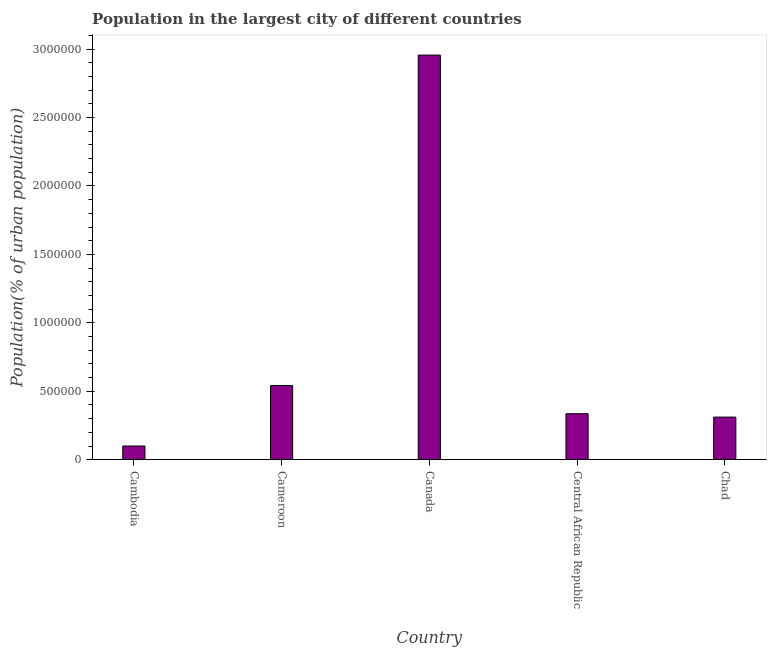What is the title of the graph?
Your answer should be compact. Population in the largest city of different countries. What is the label or title of the X-axis?
Offer a terse response. Country. What is the label or title of the Y-axis?
Your response must be concise. Population(% of urban population). What is the population in largest city in Central African Republic?
Your answer should be compact. 3.36e+05. Across all countries, what is the maximum population in largest city?
Offer a terse response. 2.96e+06. In which country was the population in largest city minimum?
Provide a short and direct response. Cambodia. What is the sum of the population in largest city?
Keep it short and to the point. 4.25e+06. What is the difference between the population in largest city in Cambodia and Central African Republic?
Your answer should be very brief. -2.36e+05. What is the average population in largest city per country?
Ensure brevity in your answer.  8.49e+05. What is the median population in largest city?
Provide a short and direct response. 3.36e+05. In how many countries, is the population in largest city greater than 2000000 %?
Make the answer very short. 1. What is the ratio of the population in largest city in Cambodia to that in Chad?
Your answer should be very brief. 0.32. Is the population in largest city in Canada less than that in Central African Republic?
Your answer should be very brief. No. What is the difference between the highest and the second highest population in largest city?
Make the answer very short. 2.41e+06. Is the sum of the population in largest city in Cameroon and Canada greater than the maximum population in largest city across all countries?
Your answer should be compact. Yes. What is the difference between the highest and the lowest population in largest city?
Offer a terse response. 2.86e+06. How many countries are there in the graph?
Ensure brevity in your answer.  5. What is the difference between two consecutive major ticks on the Y-axis?
Ensure brevity in your answer.  5.00e+05. Are the values on the major ticks of Y-axis written in scientific E-notation?
Your response must be concise. No. What is the Population(% of urban population) of Cambodia?
Ensure brevity in your answer.  1.00e+05. What is the Population(% of urban population) of Cameroon?
Your response must be concise. 5.42e+05. What is the Population(% of urban population) of Canada?
Make the answer very short. 2.96e+06. What is the Population(% of urban population) in Central African Republic?
Your response must be concise. 3.36e+05. What is the Population(% of urban population) of Chad?
Your answer should be compact. 3.11e+05. What is the difference between the Population(% of urban population) in Cambodia and Cameroon?
Give a very brief answer. -4.42e+05. What is the difference between the Population(% of urban population) in Cambodia and Canada?
Ensure brevity in your answer.  -2.86e+06. What is the difference between the Population(% of urban population) in Cambodia and Central African Republic?
Offer a very short reply. -2.36e+05. What is the difference between the Population(% of urban population) in Cambodia and Chad?
Give a very brief answer. -2.11e+05. What is the difference between the Population(% of urban population) in Cameroon and Canada?
Your answer should be very brief. -2.41e+06. What is the difference between the Population(% of urban population) in Cameroon and Central African Republic?
Give a very brief answer. 2.06e+05. What is the difference between the Population(% of urban population) in Cameroon and Chad?
Give a very brief answer. 2.31e+05. What is the difference between the Population(% of urban population) in Canada and Central African Republic?
Ensure brevity in your answer.  2.62e+06. What is the difference between the Population(% of urban population) in Canada and Chad?
Your answer should be very brief. 2.65e+06. What is the difference between the Population(% of urban population) in Central African Republic and Chad?
Make the answer very short. 2.47e+04. What is the ratio of the Population(% of urban population) in Cambodia to that in Cameroon?
Provide a short and direct response. 0.18. What is the ratio of the Population(% of urban population) in Cambodia to that in Canada?
Make the answer very short. 0.03. What is the ratio of the Population(% of urban population) in Cambodia to that in Central African Republic?
Your answer should be very brief. 0.3. What is the ratio of the Population(% of urban population) in Cambodia to that in Chad?
Ensure brevity in your answer.  0.32. What is the ratio of the Population(% of urban population) in Cameroon to that in Canada?
Offer a very short reply. 0.18. What is the ratio of the Population(% of urban population) in Cameroon to that in Central African Republic?
Make the answer very short. 1.61. What is the ratio of the Population(% of urban population) in Cameroon to that in Chad?
Give a very brief answer. 1.74. What is the ratio of the Population(% of urban population) in Canada to that in Central African Republic?
Your answer should be very brief. 8.8. What is the ratio of the Population(% of urban population) in Canada to that in Chad?
Offer a very short reply. 9.5. What is the ratio of the Population(% of urban population) in Central African Republic to that in Chad?
Offer a terse response. 1.08. 